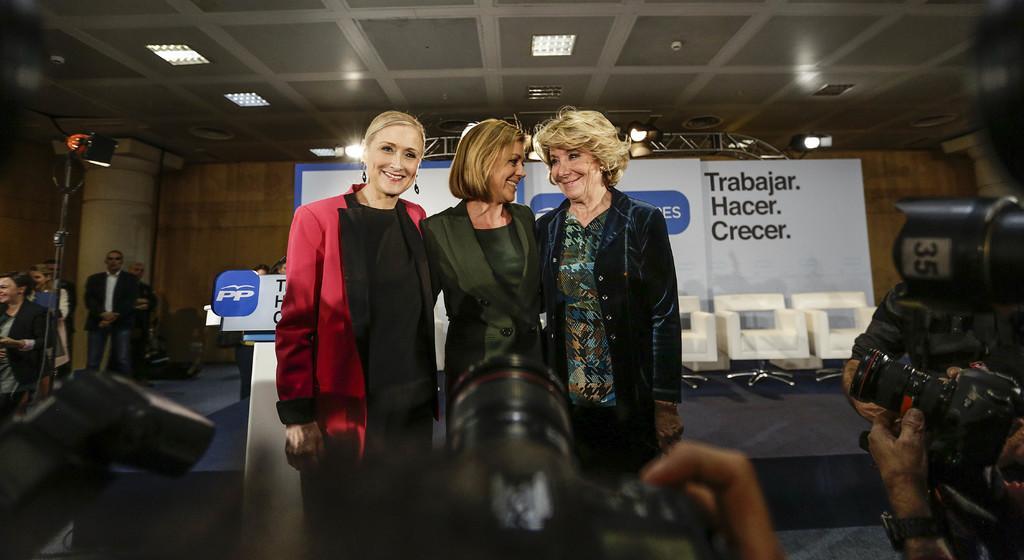How would you summarize this image in a sentence or two? 3 Beautiful women are standing and smiling at the down side these are the cameras. 